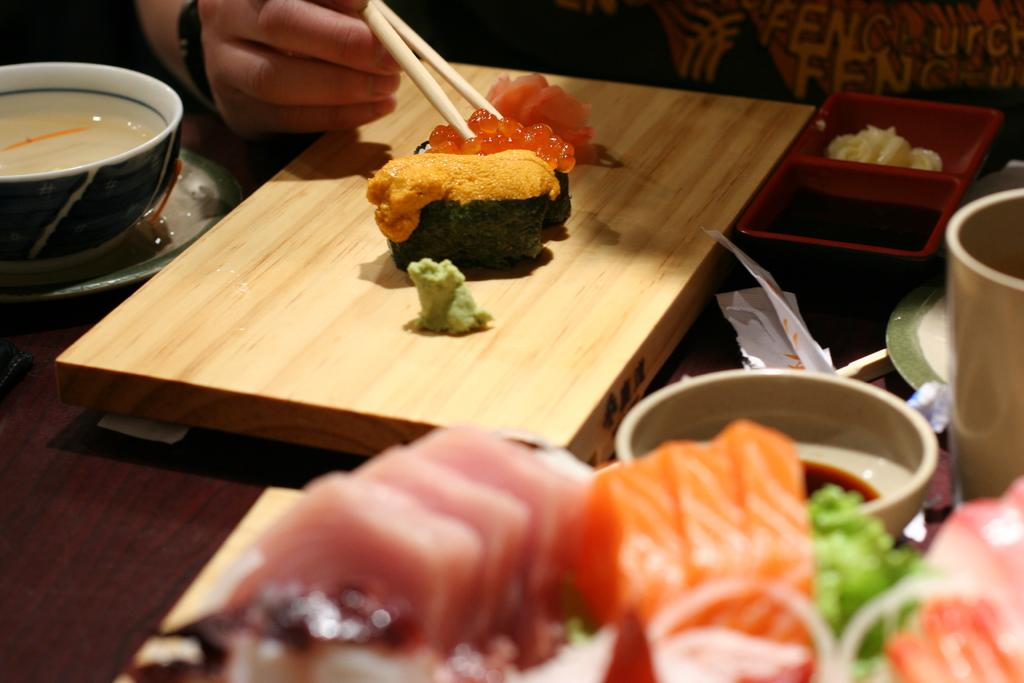What is the person holding in the image? The person is holding sticks in the image. What can be seen on the table in the image? There is a bowl, plates, a board, food, a container, and a paper on the table in the image. What might be used for serving or holding food in the image? The bowl and plates on the table can be used for serving or holding food. What is the purpose of the board on the table? The purpose of the board on the table is not clear from the image, but it could be used for serving or displaying food. How many books are visible on the table in the image? There are no books visible on the table in the image. Can you see any jellyfish on the table in the image? There are no jellyfish present in the image. 